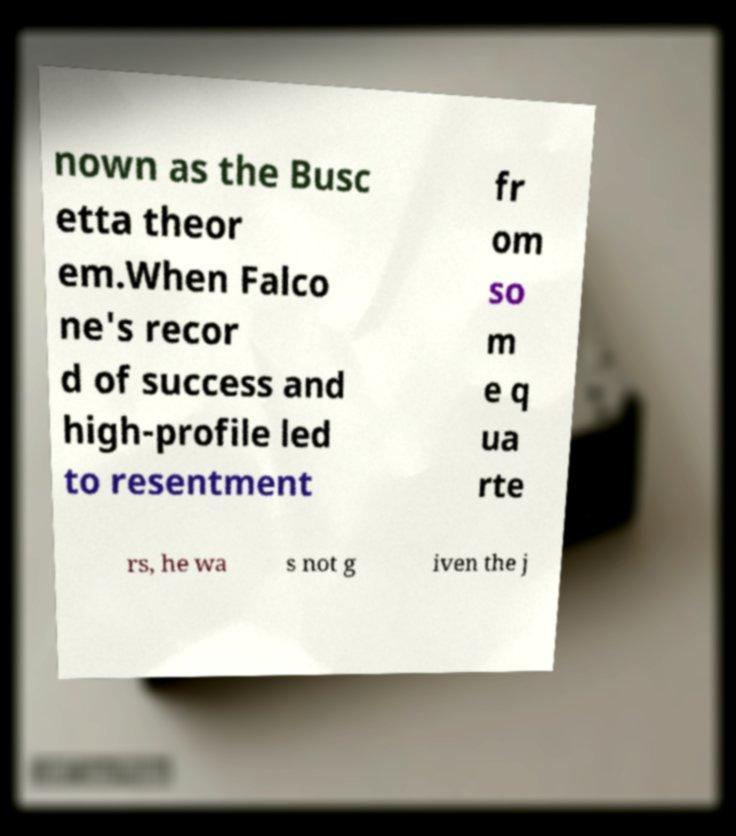Could you extract and type out the text from this image? nown as the Busc etta theor em.When Falco ne's recor d of success and high-profile led to resentment fr om so m e q ua rte rs, he wa s not g iven the j 